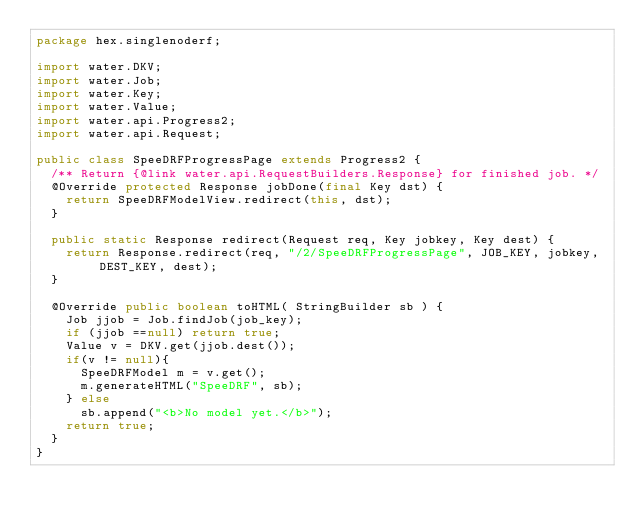Convert code to text. <code><loc_0><loc_0><loc_500><loc_500><_Java_>package hex.singlenoderf;

import water.DKV;
import water.Job;
import water.Key;
import water.Value;
import water.api.Progress2;
import water.api.Request;

public class SpeeDRFProgressPage extends Progress2 {
  /** Return {@link water.api.RequestBuilders.Response} for finished job. */
  @Override protected Response jobDone(final Key dst) {
    return SpeeDRFModelView.redirect(this, dst);
  }

  public static Response redirect(Request req, Key jobkey, Key dest) {
    return Response.redirect(req, "/2/SpeeDRFProgressPage", JOB_KEY, jobkey, DEST_KEY, dest);
  }

  @Override public boolean toHTML( StringBuilder sb ) {
    Job jjob = Job.findJob(job_key);
    if (jjob ==null) return true;
    Value v = DKV.get(jjob.dest());
    if(v != null){
      SpeeDRFModel m = v.get();
      m.generateHTML("SpeeDRF", sb);
    } else
      sb.append("<b>No model yet.</b>");
    return true;
  }
}
</code> 